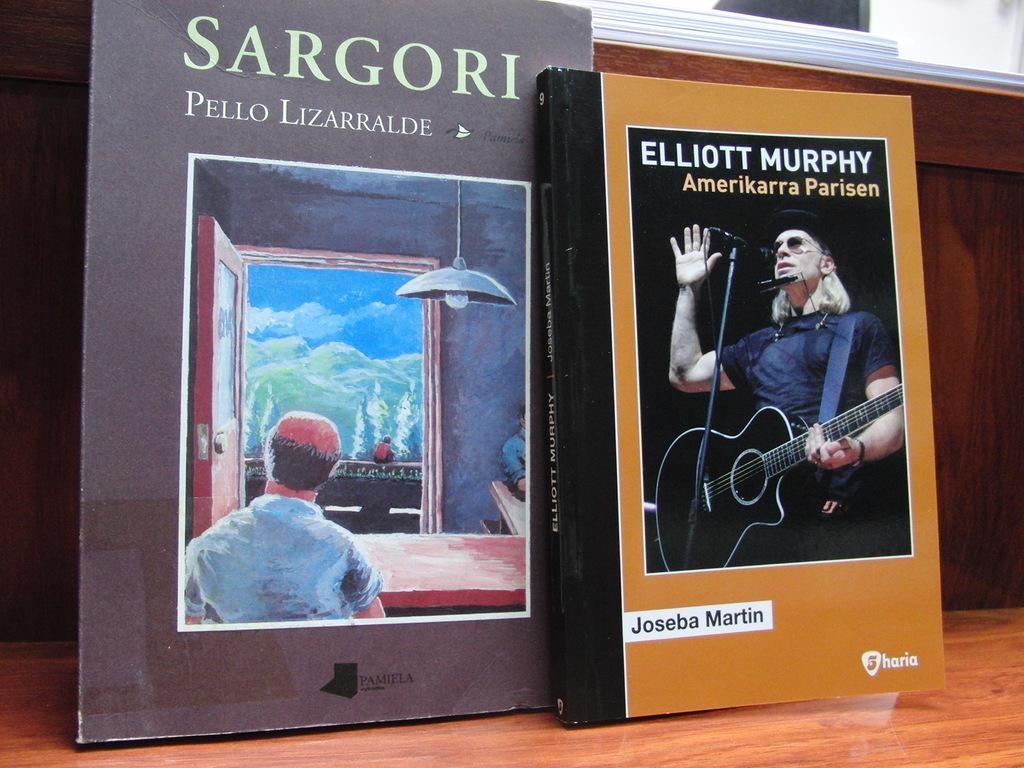Please provide a concise description of this image. He is standing and his playing a guitar. There is a table. There is a book on a table. 